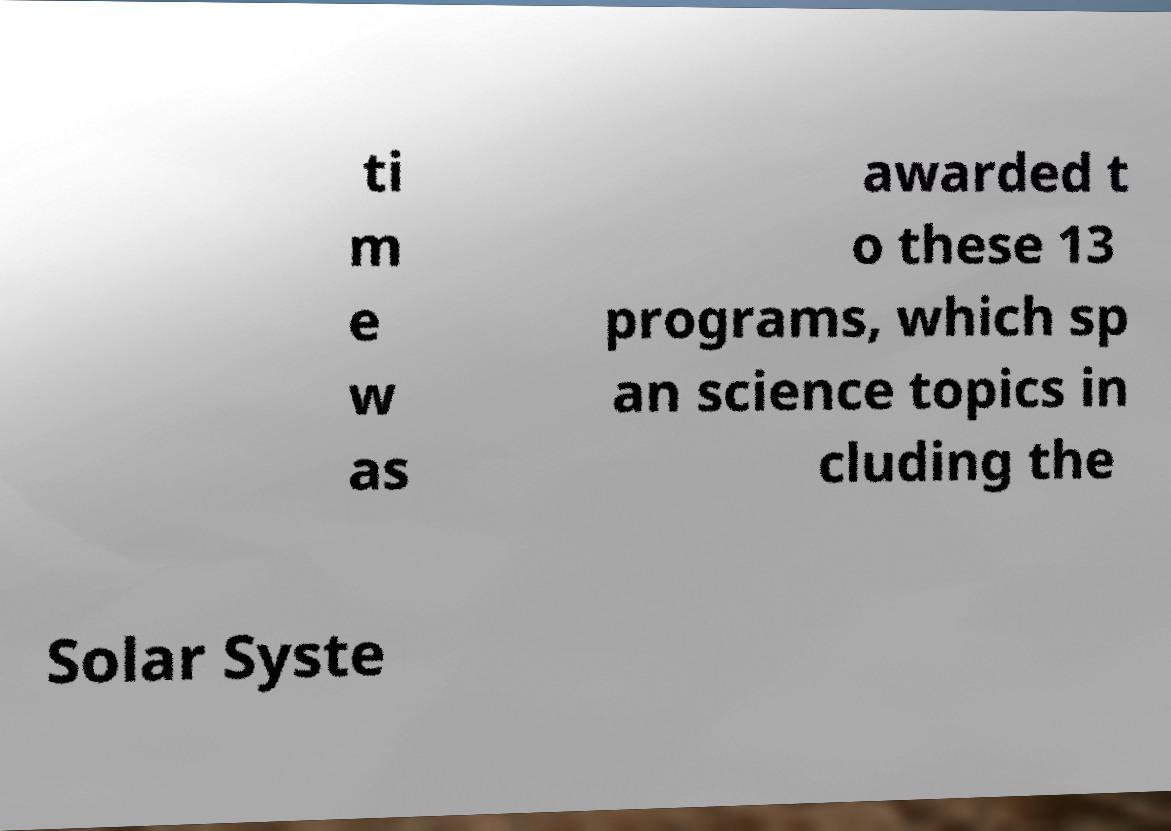What messages or text are displayed in this image? I need them in a readable, typed format. ti m e w as awarded t o these 13 programs, which sp an science topics in cluding the Solar Syste 